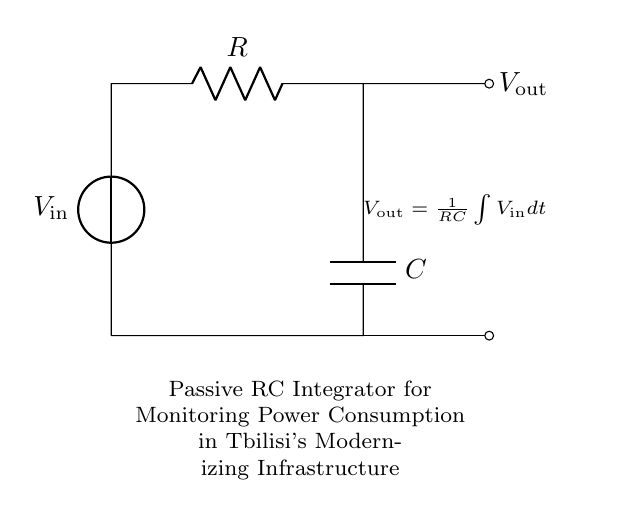What are the components in this circuit? The components in the circuit are a voltage source, a resistor, and a capacitor. These are indicated by the symbols in the diagram.
Answer: voltage source, resistor, capacitor What is the role of the capacitor in this circuit? The capacitor in an RC integrator circuit acts to smooth out changes in voltage over time, integrating the input voltage to produce a corresponding output voltage that reflects the accumulated charge.
Answer: smooth out voltage changes What is the output voltage expression in this circuit? The output voltage expression is given by the formula displayed in the circuit, which states that the output voltage equals the integral of the input voltage over time, divided by the product of resistance and capacitance.
Answer: output voltage = (1/RC) integral of input voltage dt How does increasing the resistance affect the output voltage? Increasing the resistance in this passive RC integrator circuit will slow down the charging time of the capacitor, which implies that the output voltage will take longer to reach its eventual steady-state value, leading to a longer time constant.
Answer: slows down output response What is the time constant of this RC circuit? The time constant is calculated as the product of the resistance and capacitance in the circuit, which indicates the time it takes for the capacitor to charge to about 63.2% of the input voltage. This is significant for determining how quickly the circuit responds to changes in power consumption.
Answer: RC What is the significance of this circuit for monitoring power consumption? This passive RC integrator circuit provides a means to monitor and average out power consumption levels over time, which is particularly useful in modernizing infrastructure in Tbilisi for managing electrical loads and ensuring stability.
Answer: averages power consumption 